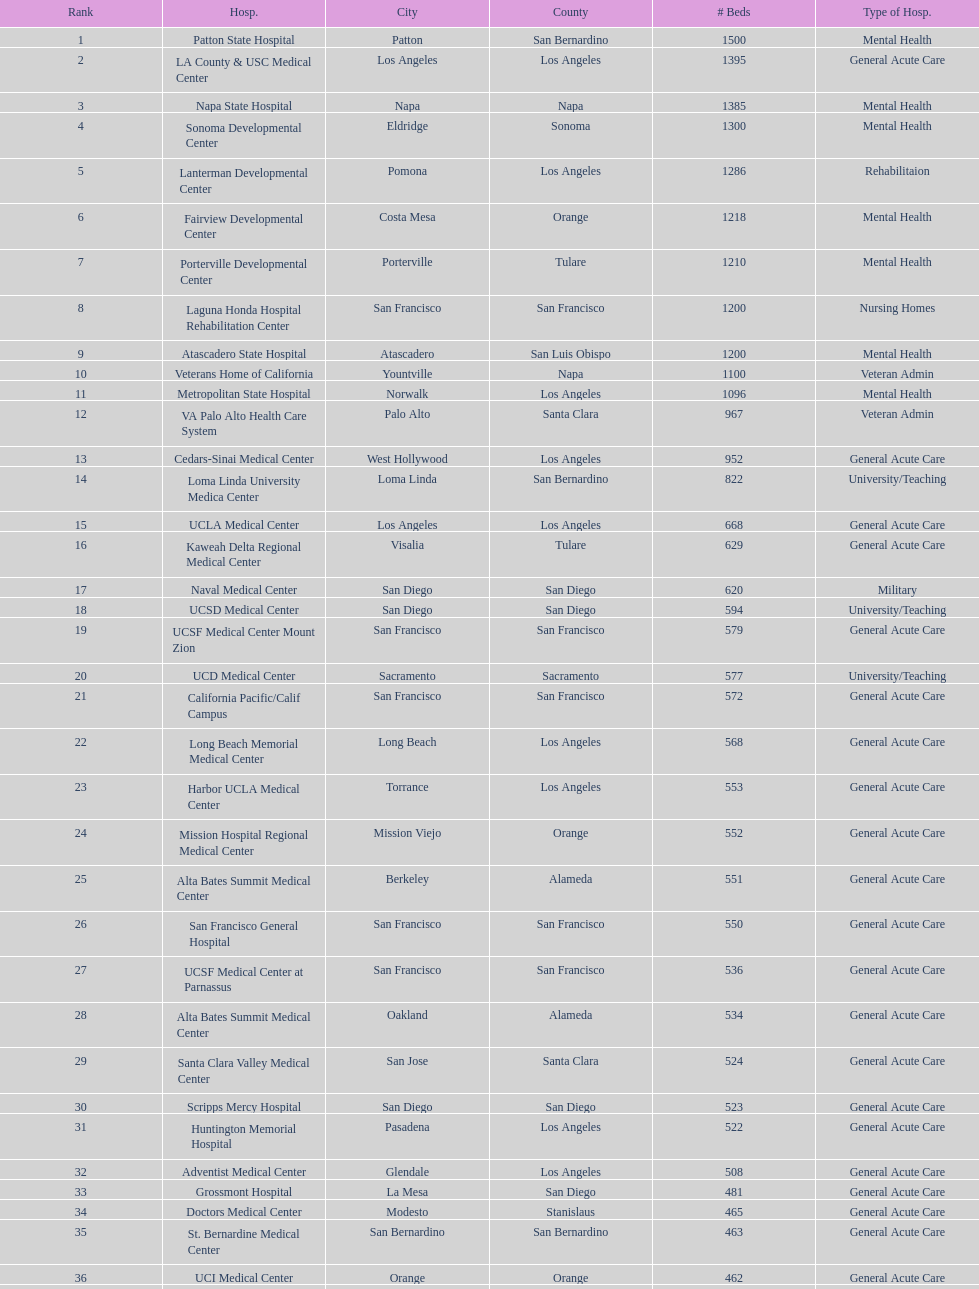How many hospitals have at least 1,000 beds? 11. 